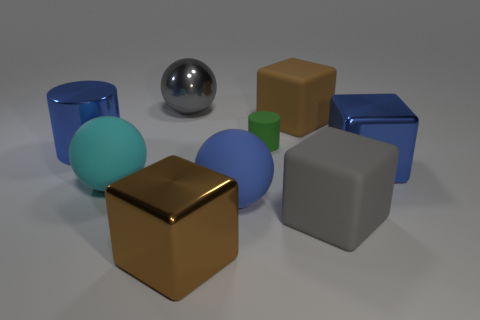Add 1 big gray matte objects. How many objects exist? 10 Subtract all spheres. How many objects are left? 6 Subtract 0 green cubes. How many objects are left? 9 Subtract all large gray shiny objects. Subtract all tiny gray blocks. How many objects are left? 8 Add 1 big brown metal objects. How many big brown metal objects are left? 2 Add 5 matte cylinders. How many matte cylinders exist? 6 